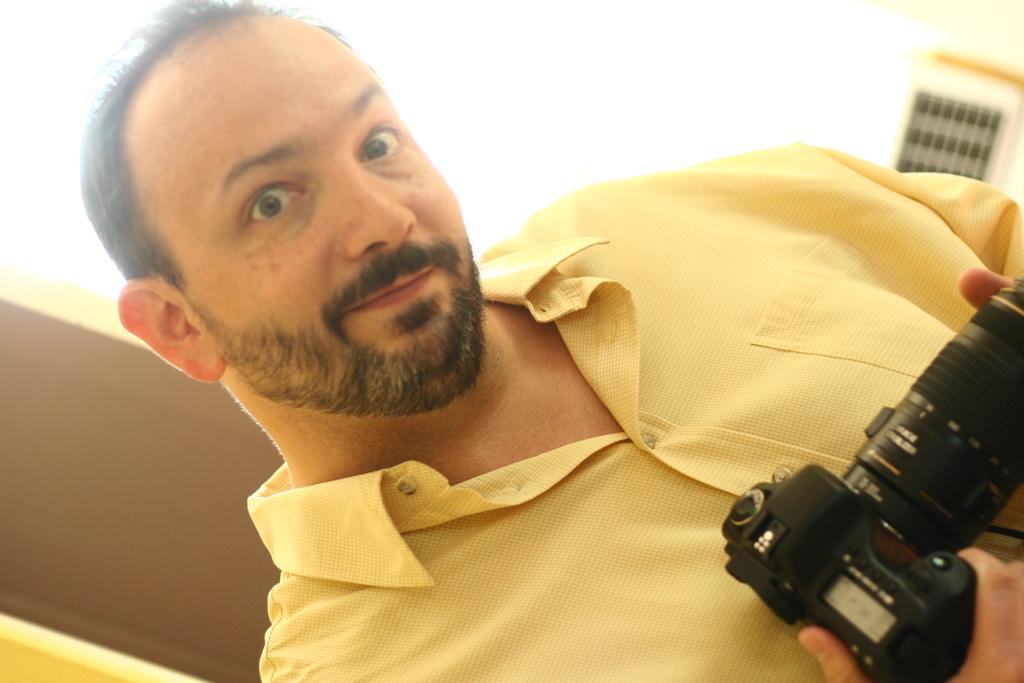Who or what is the main subject in the image? There is a person in the image. What is the person holding in the image? The person is holding a camera. What can be seen in the background of the image? There is a door and a wall in the background of the image. What type of cream is being applied to the person's face in the image? There is no cream being applied to the person's face in the image; the person is holding a camera. What kind of band is performing in the image? There is no band performing in the image; it features a person holding a camera. 